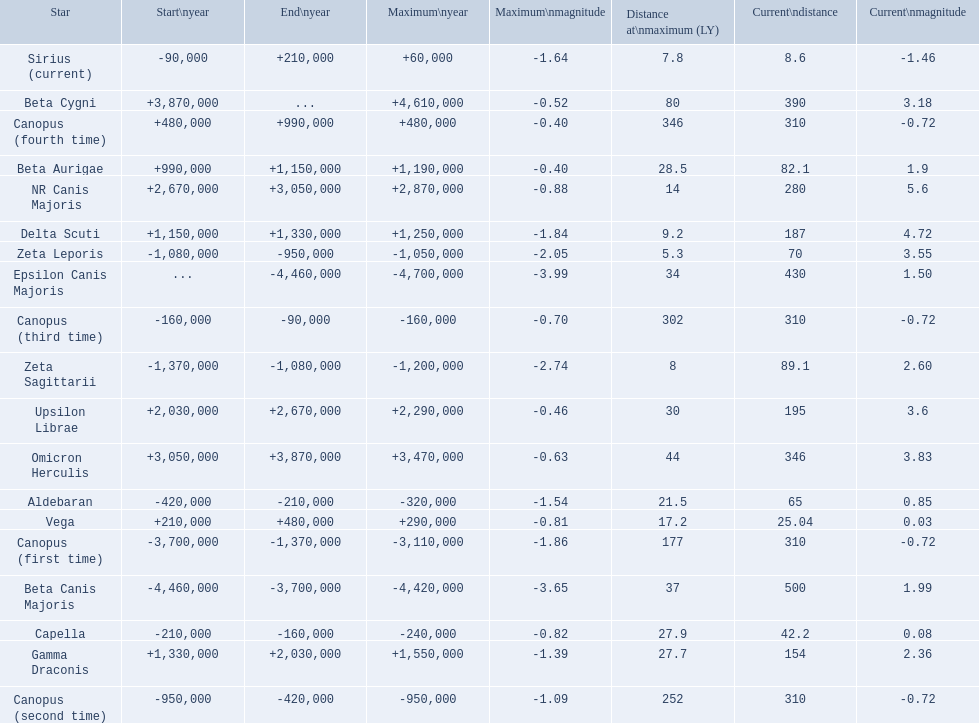What are the historical brightest stars? Epsilon Canis Majoris, Beta Canis Majoris, Canopus (first time), Zeta Sagittarii, Zeta Leporis, Canopus (second time), Aldebaran, Capella, Canopus (third time), Sirius (current), Vega, Canopus (fourth time), Beta Aurigae, Delta Scuti, Gamma Draconis, Upsilon Librae, NR Canis Majoris, Omicron Herculis, Beta Cygni. Would you mind parsing the complete table? {'header': ['Star', 'Start\\nyear', 'End\\nyear', 'Maximum\\nyear', 'Maximum\\nmagnitude', 'Distance at\\nmaximum (LY)', 'Current\\ndistance', 'Current\\nmagnitude'], 'rows': [['Sirius (current)', '-90,000', '+210,000', '+60,000', '-1.64', '7.8', '8.6', '-1.46'], ['Beta Cygni', '+3,870,000', '...', '+4,610,000', '-0.52', '80', '390', '3.18'], ['Canopus (fourth time)', '+480,000', '+990,000', '+480,000', '-0.40', '346', '310', '-0.72'], ['Beta Aurigae', '+990,000', '+1,150,000', '+1,190,000', '-0.40', '28.5', '82.1', '1.9'], ['NR Canis Majoris', '+2,670,000', '+3,050,000', '+2,870,000', '-0.88', '14', '280', '5.6'], ['Delta Scuti', '+1,150,000', '+1,330,000', '+1,250,000', '-1.84', '9.2', '187', '4.72'], ['Zeta Leporis', '-1,080,000', '-950,000', '-1,050,000', '-2.05', '5.3', '70', '3.55'], ['Epsilon Canis Majoris', '...', '-4,460,000', '-4,700,000', '-3.99', '34', '430', '1.50'], ['Canopus (third time)', '-160,000', '-90,000', '-160,000', '-0.70', '302', '310', '-0.72'], ['Zeta Sagittarii', '-1,370,000', '-1,080,000', '-1,200,000', '-2.74', '8', '89.1', '2.60'], ['Upsilon Librae', '+2,030,000', '+2,670,000', '+2,290,000', '-0.46', '30', '195', '3.6'], ['Omicron Herculis', '+3,050,000', '+3,870,000', '+3,470,000', '-0.63', '44', '346', '3.83'], ['Aldebaran', '-420,000', '-210,000', '-320,000', '-1.54', '21.5', '65', '0.85'], ['Vega', '+210,000', '+480,000', '+290,000', '-0.81', '17.2', '25.04', '0.03'], ['Canopus (first time)', '-3,700,000', '-1,370,000', '-3,110,000', '-1.86', '177', '310', '-0.72'], ['Beta Canis Majoris', '-4,460,000', '-3,700,000', '-4,420,000', '-3.65', '37', '500', '1.99'], ['Capella', '-210,000', '-160,000', '-240,000', '-0.82', '27.9', '42.2', '0.08'], ['Gamma Draconis', '+1,330,000', '+2,030,000', '+1,550,000', '-1.39', '27.7', '154', '2.36'], ['Canopus (second time)', '-950,000', '-420,000', '-950,000', '-1.09', '252', '310', '-0.72']]} Of those which star has a distance at maximum of 80 Beta Cygni. 